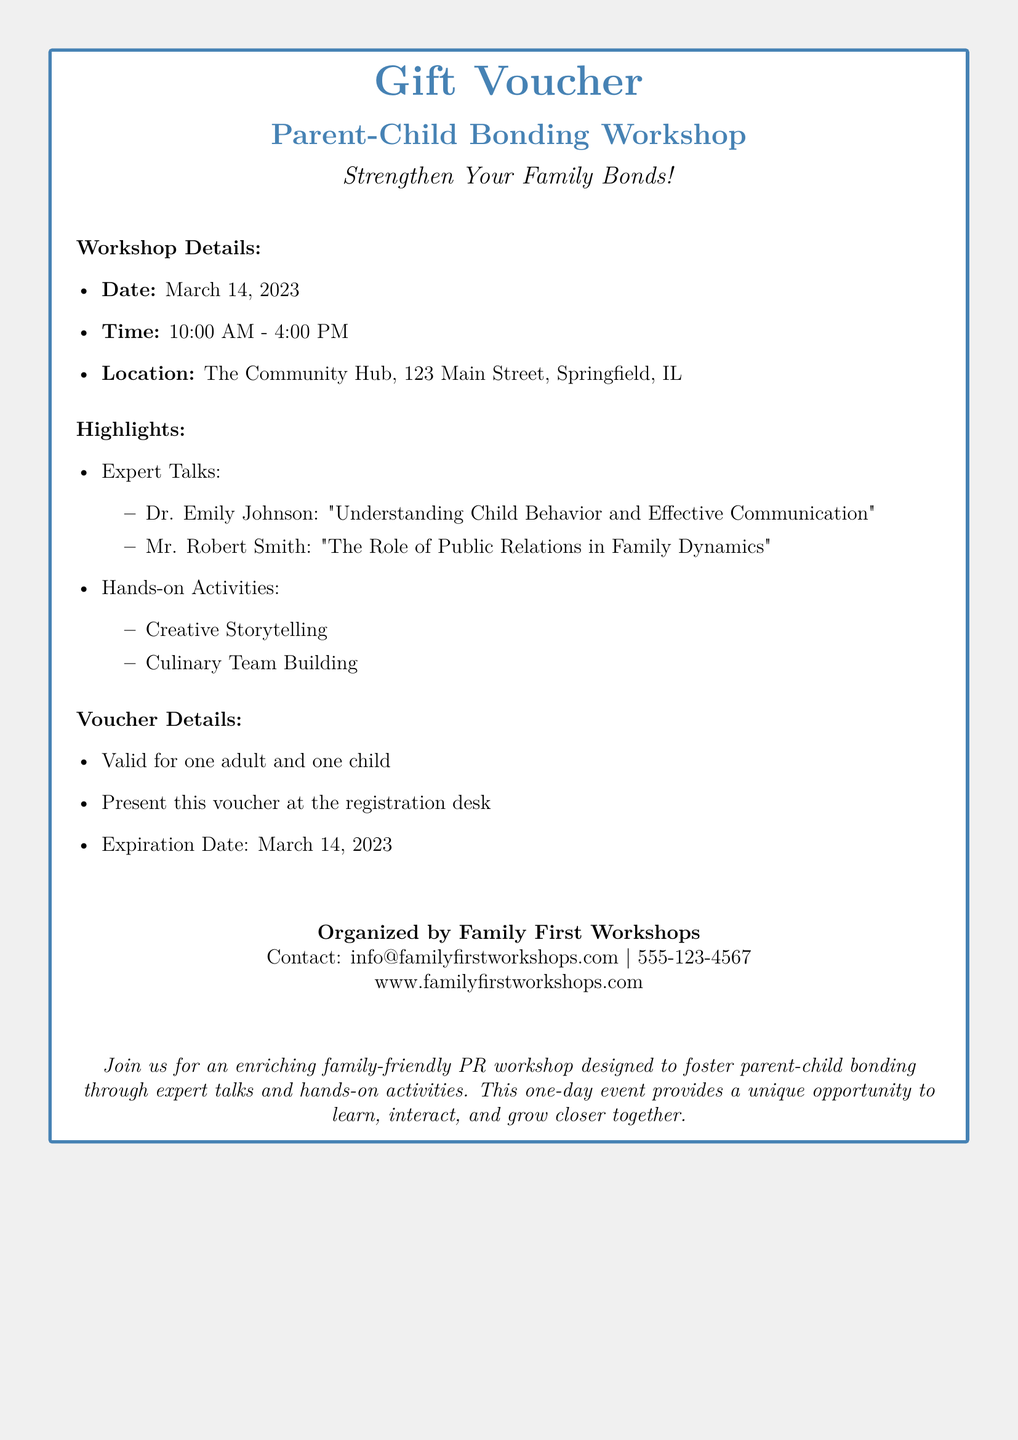what is the date of the workshop? The date of the workshop is clearly stated in the document.
Answer: March 14, 2023 what is the location of the workshop? The location is specified in the workshop details section.
Answer: The Community Hub, 123 Main Street, Springfield, IL who is the first speaker? The document lists the expert talks along with the speakers' names.
Answer: Dr. Emily Johnson what is one of the hands-on activities? The document provides information on various hands-on activities that are included in the workshop.
Answer: Creative Storytelling what is the expiration date of the voucher? The expiration date is mentioned in the voucher details section.
Answer: March 14, 2023 how many participants does the voucher cover? The voucher details state the number of participants it is valid for.
Answer: One adult and one child what is the primary focus of the workshop? The introduction highlights the main goal of the workshop.
Answer: Strengthen Your Family Bonds what is the contact email for the organizers? The document includes contact information for the organizing body.
Answer: info@familyfirstworkshops.com what is the time duration of the workshop? The time is mentioned in the workshop details section.
Answer: 10:00 AM - 4:00 PM 